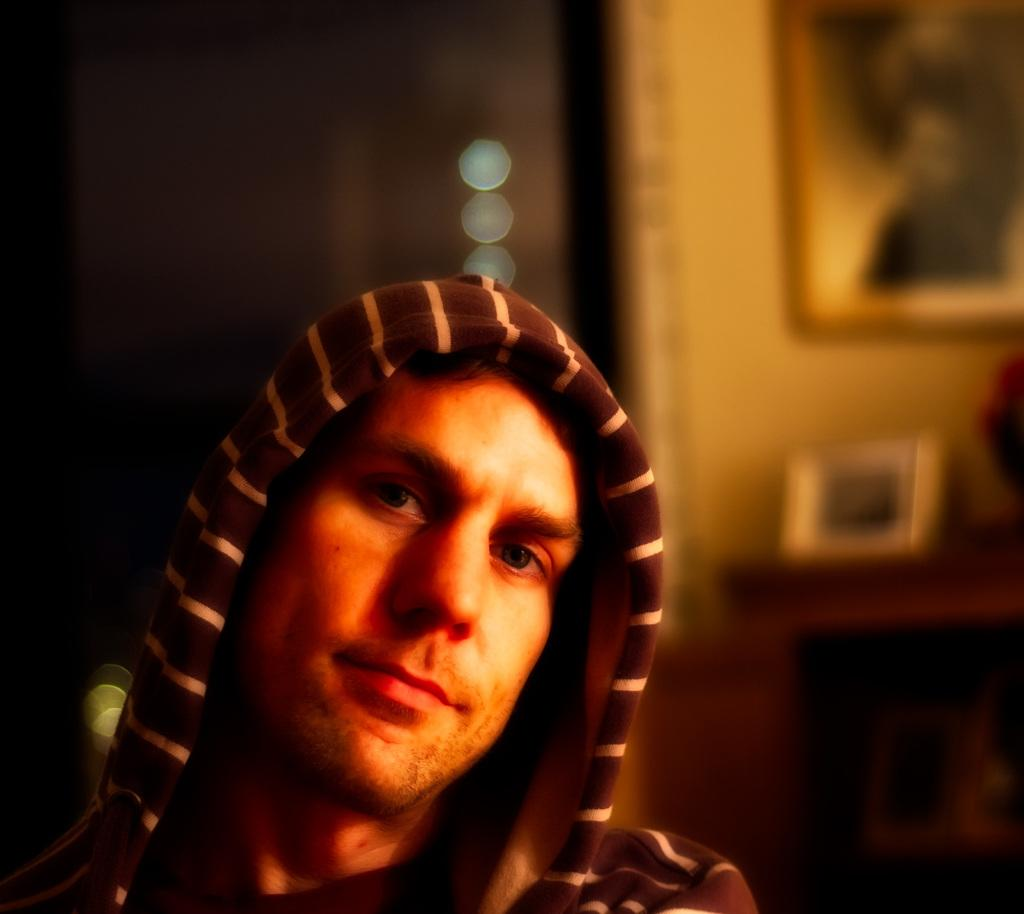Who is present in the image? There is a man in the image. What is the man wearing on his upper body? The man is wearing a jacket. What is the man wearing on his head? The man is wearing a cap on his head. What can be seen on the wall in the image? There is a photo frame on the wall in the image. What type of furniture is present in the image? There is a cupboard in the image. What is placed on the cupboard? There is a flower vase and a small photo frame on the cupboard. What type of instrument is the man playing in the image? There is no instrument present in the image; the man is not playing any instrument. 